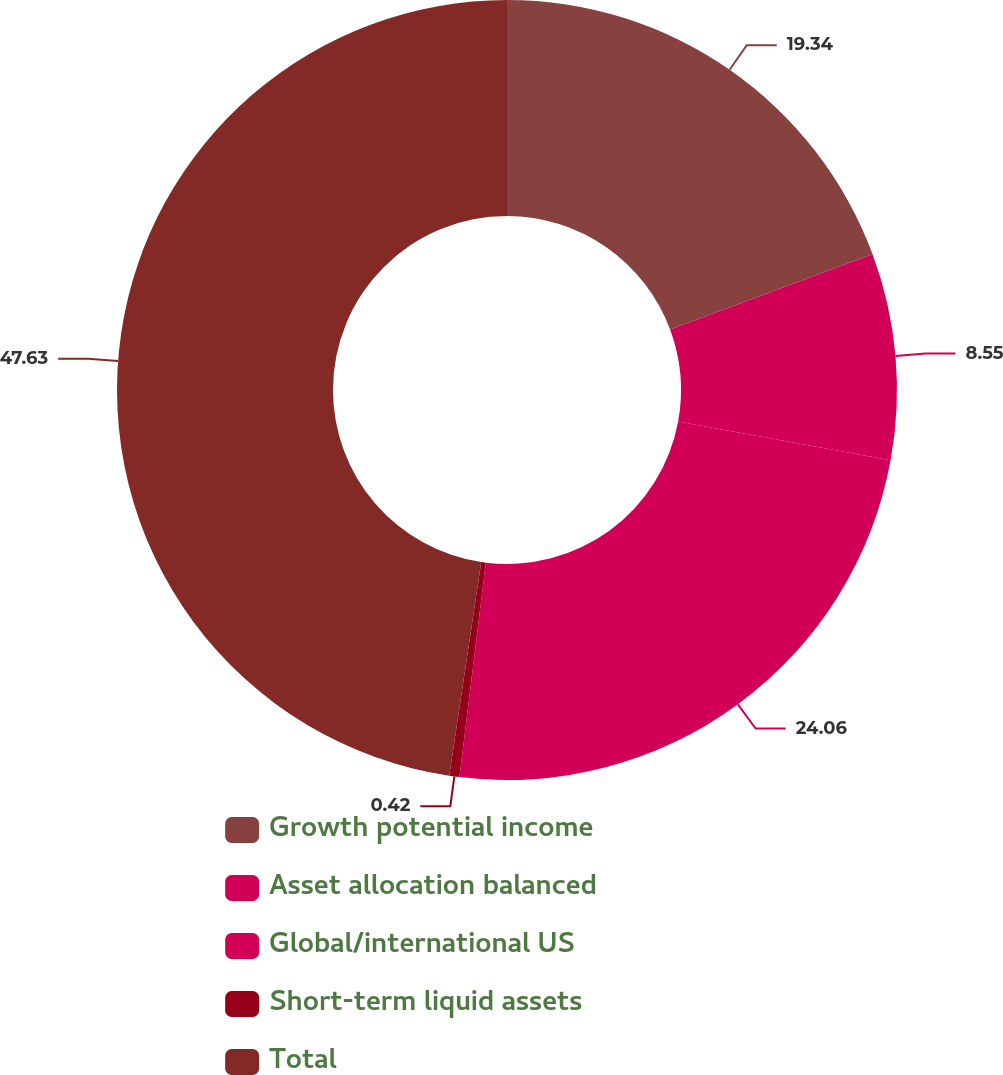Convert chart. <chart><loc_0><loc_0><loc_500><loc_500><pie_chart><fcel>Growth potential income<fcel>Asset allocation balanced<fcel>Global/international US<fcel>Short-term liquid assets<fcel>Total<nl><fcel>19.34%<fcel>8.55%<fcel>24.06%<fcel>0.42%<fcel>47.64%<nl></chart> 